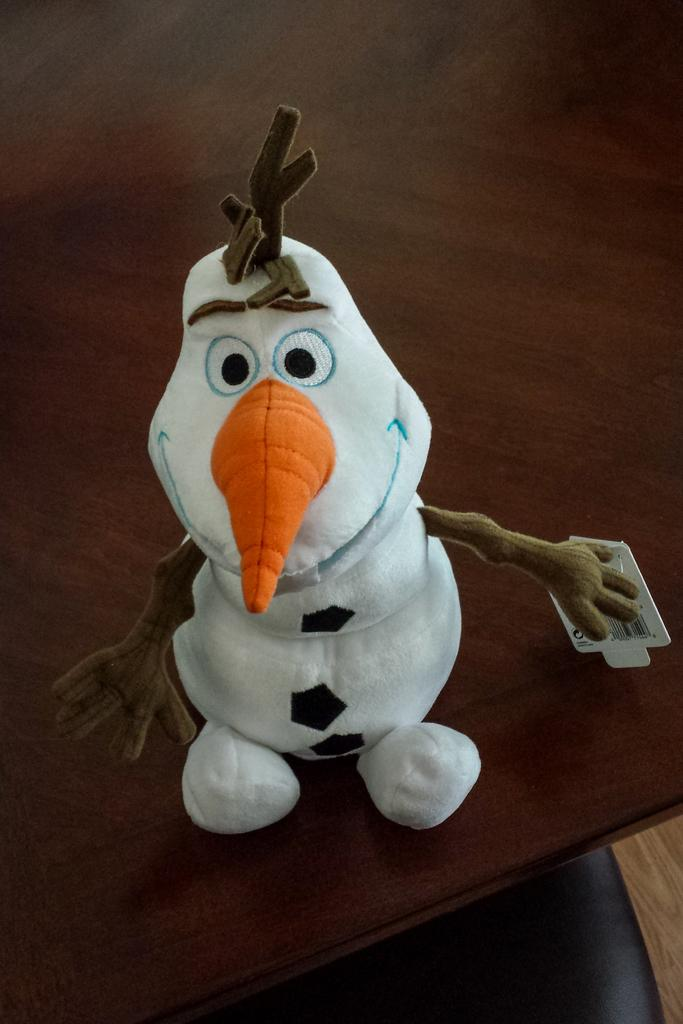What is the main subject of the image? There is a doll in the image. Can you describe the object on the table in the image? Unfortunately, the facts provided do not give any details about the object on the table. However, we can confirm that there is an object on the table. How many buckets are visible in the image? There are no buckets present in the image. Can you describe the skirt on the doll in the image? The facts provided do not mention any skirt on the doll. 